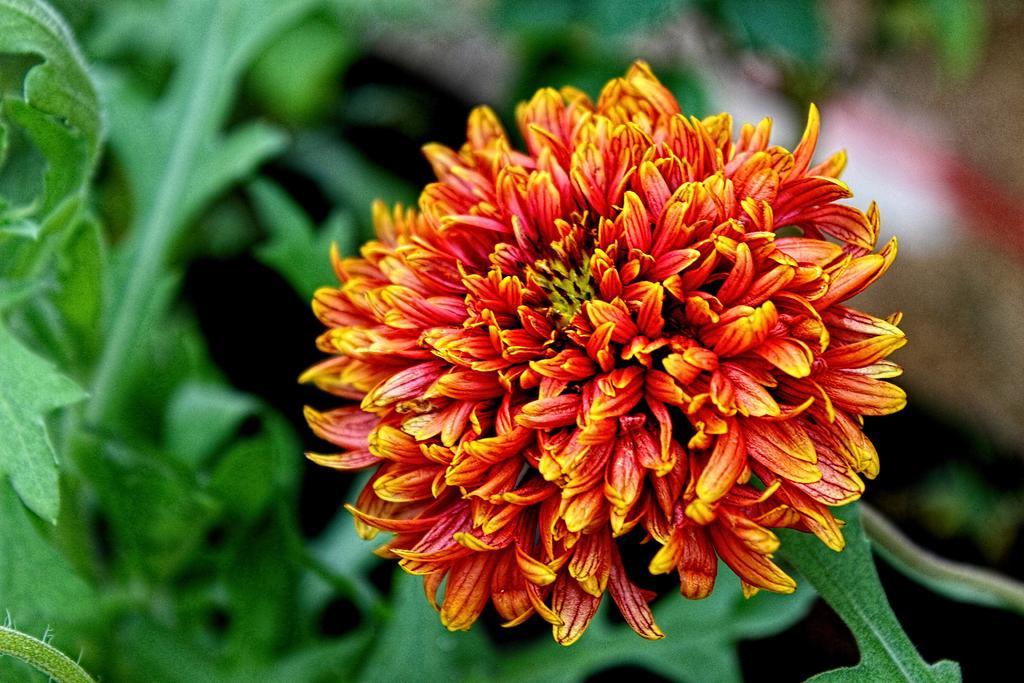In one or two sentences, can you explain what this image depicts? In the image there is a flower in the middle. In the background there are green leaves. 